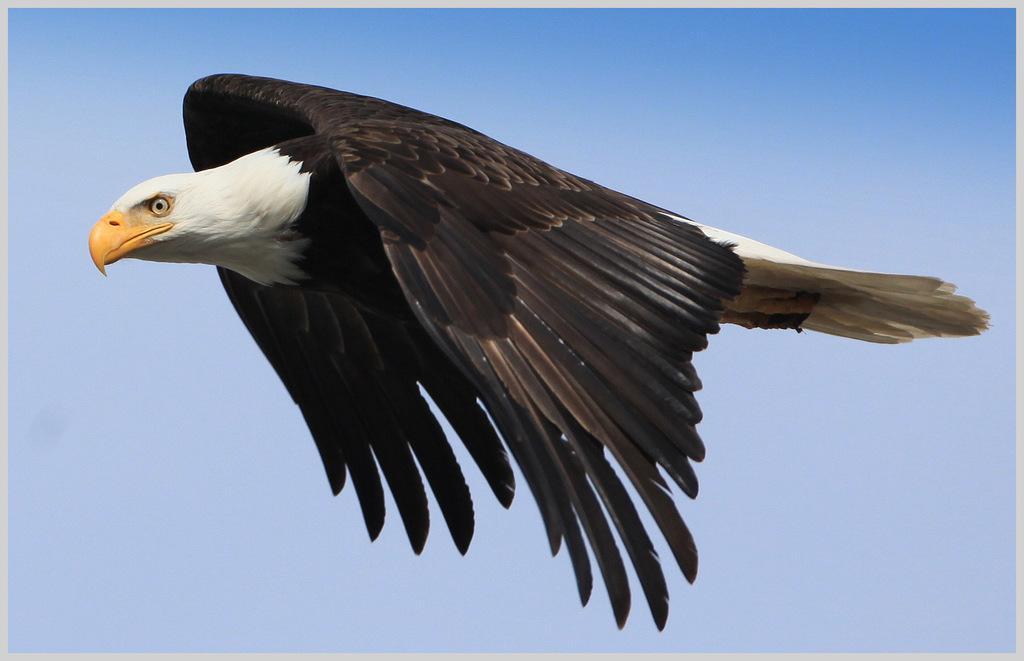Describe this image in one or two sentences. In the picture I can see an eagle flying in the sky. There are clouds in the sky. 